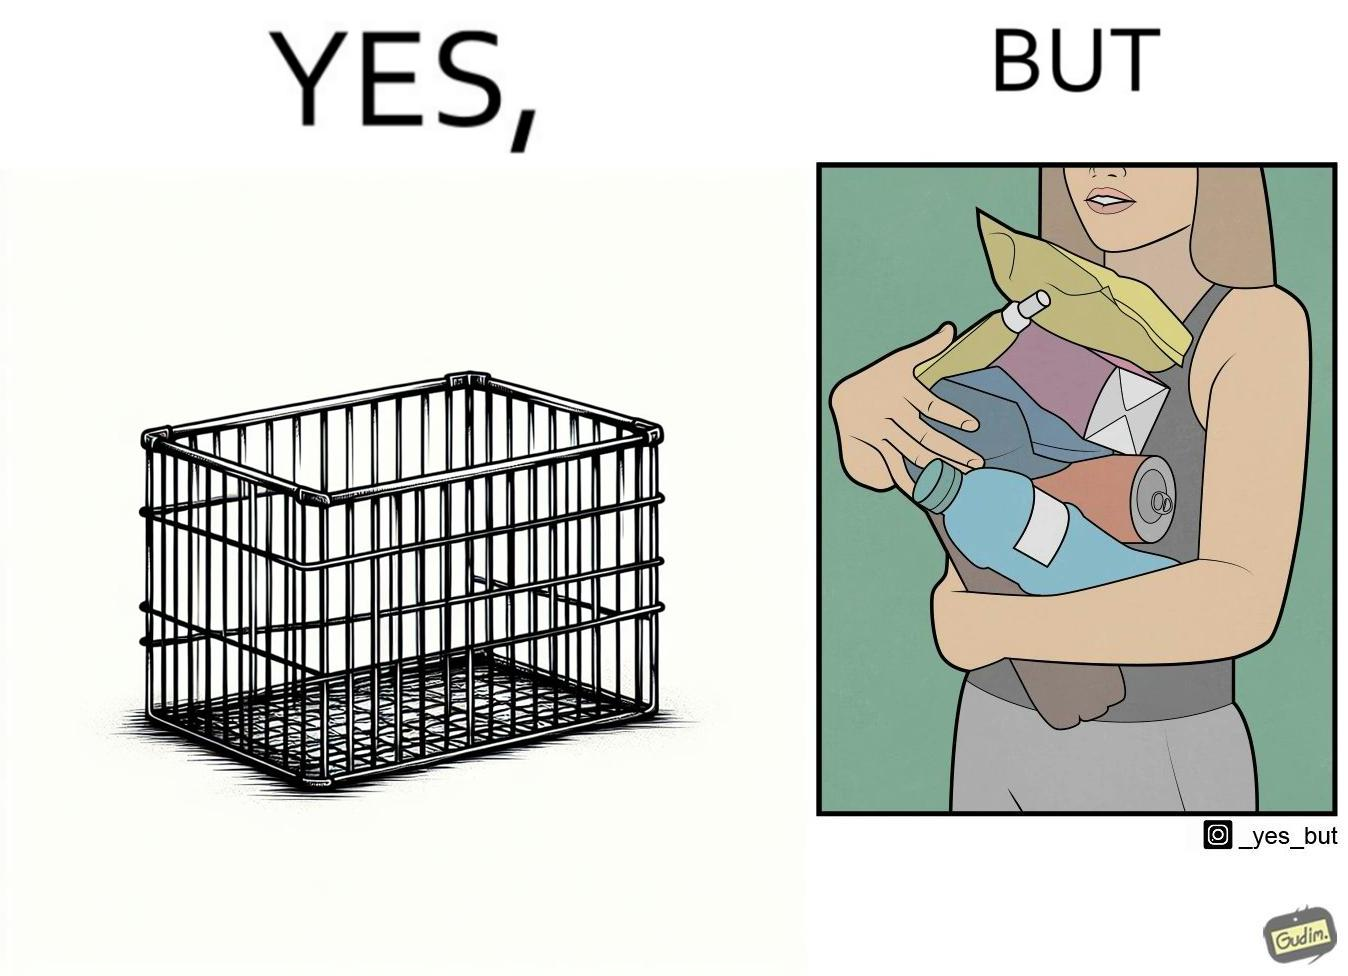Does this image contain satire or humor? Yes, this image is satirical. 